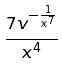<formula> <loc_0><loc_0><loc_500><loc_500>\frac { 7 v ^ { - \frac { 1 } { x ^ { 7 } } } } { x ^ { 4 } }</formula> 